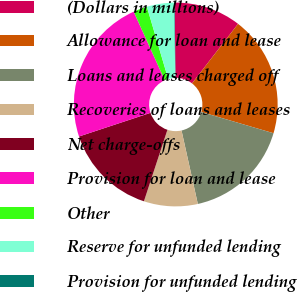Convert chart to OTSL. <chart><loc_0><loc_0><loc_500><loc_500><pie_chart><fcel>(Dollars in millions)<fcel>Allowance for loan and lease<fcel>Loans and leases charged off<fcel>Recoveries of loans and leases<fcel>Net charge-offs<fcel>Provision for loan and lease<fcel>Other<fcel>Reserve for unfunded lending<fcel>Provision for unfunded lending<nl><fcel>10.64%<fcel>19.08%<fcel>16.97%<fcel>8.53%<fcel>14.86%<fcel>23.31%<fcel>2.2%<fcel>4.31%<fcel>0.09%<nl></chart> 